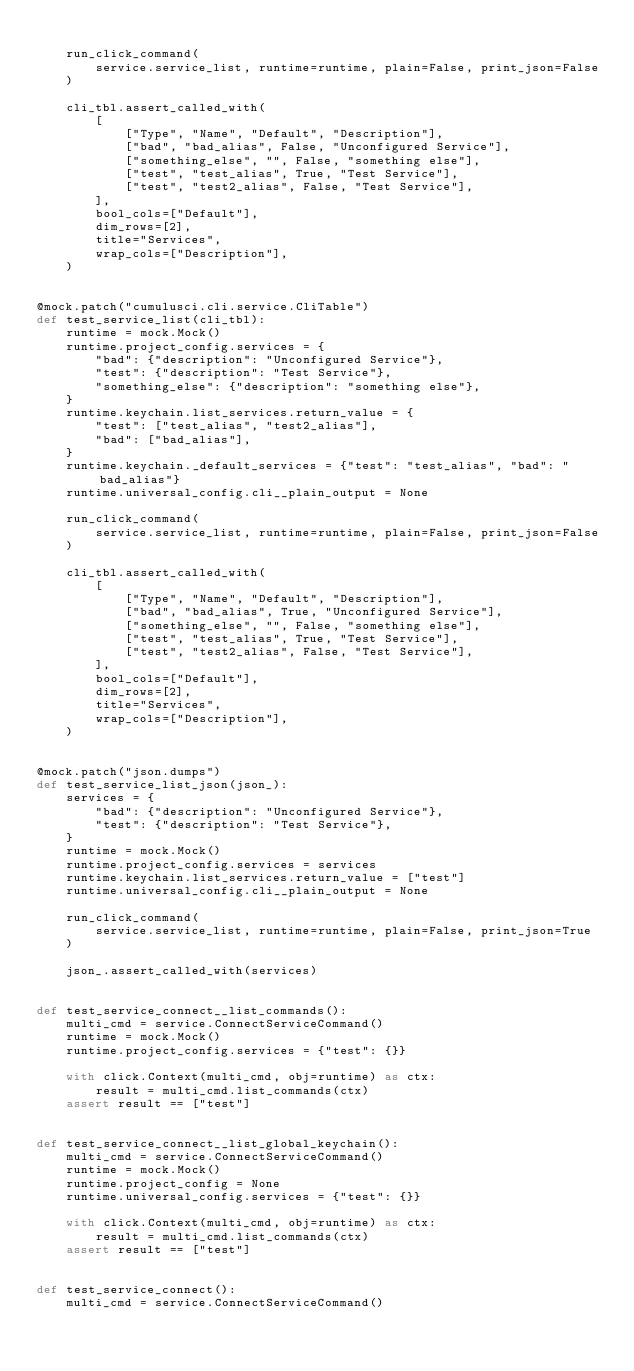Convert code to text. <code><loc_0><loc_0><loc_500><loc_500><_Python_>
    run_click_command(
        service.service_list, runtime=runtime, plain=False, print_json=False
    )

    cli_tbl.assert_called_with(
        [
            ["Type", "Name", "Default", "Description"],
            ["bad", "bad_alias", False, "Unconfigured Service"],
            ["something_else", "", False, "something else"],
            ["test", "test_alias", True, "Test Service"],
            ["test", "test2_alias", False, "Test Service"],
        ],
        bool_cols=["Default"],
        dim_rows=[2],
        title="Services",
        wrap_cols=["Description"],
    )


@mock.patch("cumulusci.cli.service.CliTable")
def test_service_list(cli_tbl):
    runtime = mock.Mock()
    runtime.project_config.services = {
        "bad": {"description": "Unconfigured Service"},
        "test": {"description": "Test Service"},
        "something_else": {"description": "something else"},
    }
    runtime.keychain.list_services.return_value = {
        "test": ["test_alias", "test2_alias"],
        "bad": ["bad_alias"],
    }
    runtime.keychain._default_services = {"test": "test_alias", "bad": "bad_alias"}
    runtime.universal_config.cli__plain_output = None

    run_click_command(
        service.service_list, runtime=runtime, plain=False, print_json=False
    )

    cli_tbl.assert_called_with(
        [
            ["Type", "Name", "Default", "Description"],
            ["bad", "bad_alias", True, "Unconfigured Service"],
            ["something_else", "", False, "something else"],
            ["test", "test_alias", True, "Test Service"],
            ["test", "test2_alias", False, "Test Service"],
        ],
        bool_cols=["Default"],
        dim_rows=[2],
        title="Services",
        wrap_cols=["Description"],
    )


@mock.patch("json.dumps")
def test_service_list_json(json_):
    services = {
        "bad": {"description": "Unconfigured Service"},
        "test": {"description": "Test Service"},
    }
    runtime = mock.Mock()
    runtime.project_config.services = services
    runtime.keychain.list_services.return_value = ["test"]
    runtime.universal_config.cli__plain_output = None

    run_click_command(
        service.service_list, runtime=runtime, plain=False, print_json=True
    )

    json_.assert_called_with(services)


def test_service_connect__list_commands():
    multi_cmd = service.ConnectServiceCommand()
    runtime = mock.Mock()
    runtime.project_config.services = {"test": {}}

    with click.Context(multi_cmd, obj=runtime) as ctx:
        result = multi_cmd.list_commands(ctx)
    assert result == ["test"]


def test_service_connect__list_global_keychain():
    multi_cmd = service.ConnectServiceCommand()
    runtime = mock.Mock()
    runtime.project_config = None
    runtime.universal_config.services = {"test": {}}

    with click.Context(multi_cmd, obj=runtime) as ctx:
        result = multi_cmd.list_commands(ctx)
    assert result == ["test"]


def test_service_connect():
    multi_cmd = service.ConnectServiceCommand()</code> 